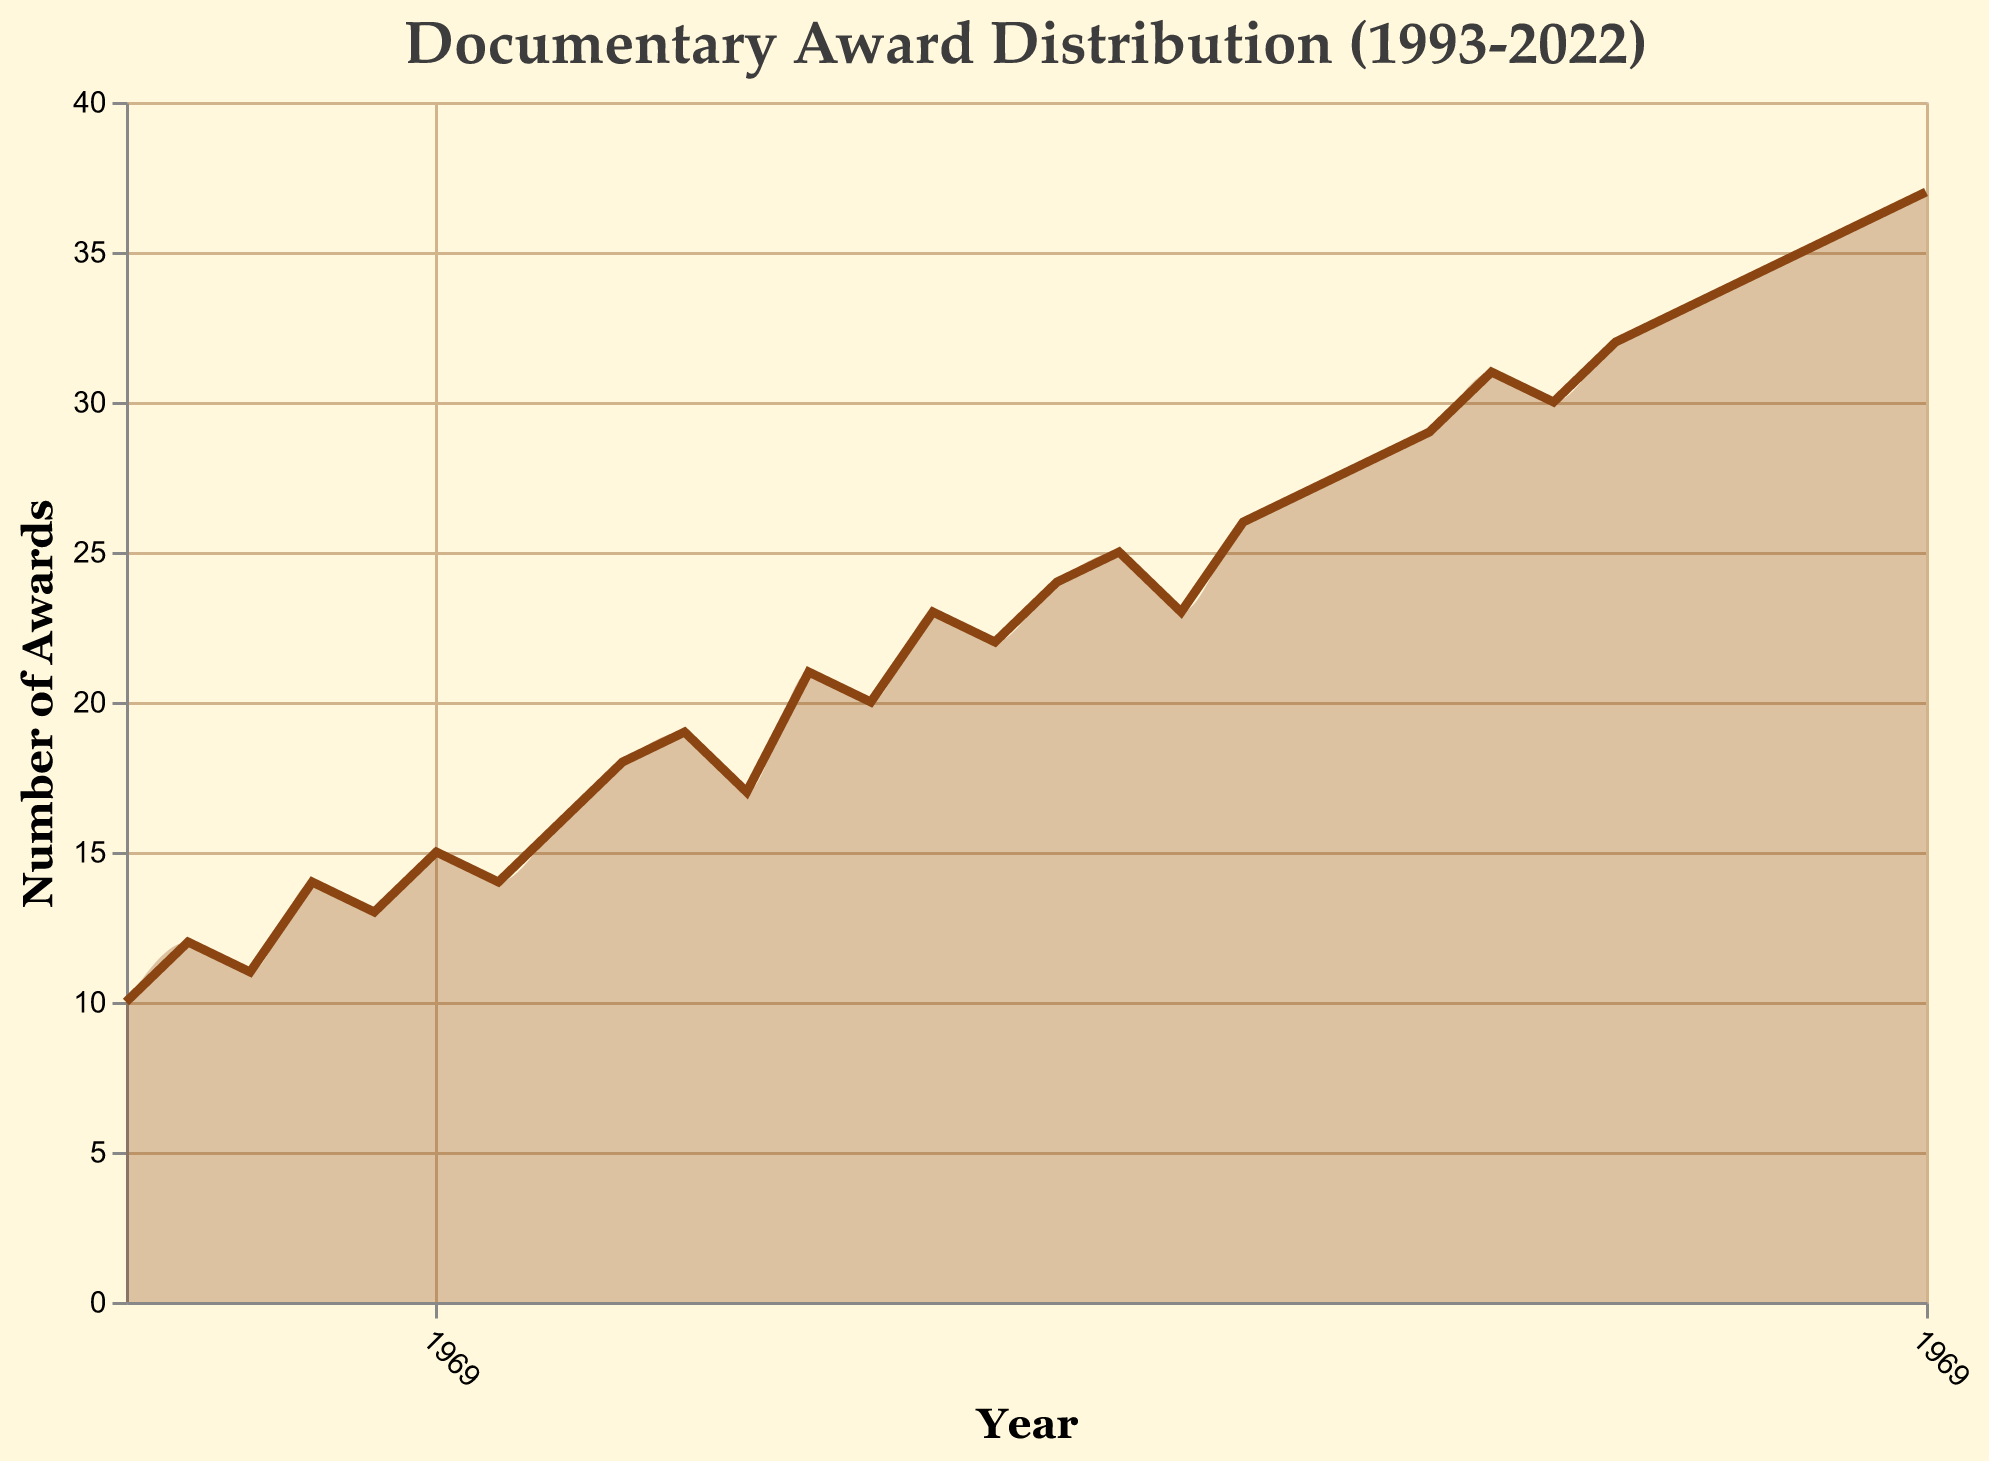What is the title of the figure? The title is prominently displayed at the top of the chart, representing the main subject of the visualization. The title reads "Documentary Award Distribution (1993-2022)", indicating it covers the frequency distribution of documentary awards over the last three decades.
Answer: Documentary Award Distribution (1993-2022) What is the value of awards in the year 2000? To find this, look at the data point corresponding to the year 2000 along the horizontal (x) axis and see its height on the vertical (y) axis. The data point indicates that the number of awards in 2000 was 16.
Answer: 16 In which year was the highest number of awards given? The highest point on the vertical (y) axis will represent the highest number of awards received in a year. By locating the peak, we see that the highest number of awards (37) was given in the year 2022.
Answer: 2022 By how much did the number of awards increase from 1993 to 2022? The number of awards in 1993 was 10, and it increased to 37 in 2022. The increase can be calculated by subtracting the number of awards in 1993 from the number of awards in 2022: 37 - 10.
Answer: 27 During which decade did the number of awards experience the most significant increase? Divide the data into decades and compare the increase in the number of awards within each decade. From 1993 to 2002, the awards increased from 10 to 19 (a difference of 9). From 2003 to 2012, it increased from 17 to 27 (a difference of 10). From 2013 to 2022, it increased from 29 to 37 (a difference of 8). The decade with the most significant increase is from 2003 to 2012.
Answer: 2003-2012 What is the average number of awards given per year over the three decades? Sum all the awards from 1993 to 2022 and divide by the number of years (30). The total sum of awards is 30 + 12 + 11 + 14 + 13 + 15 + 14 + 16 + 18 + 19 + 17 + 21 + 20 + 23 + 22 + 24 + 25 + 23 + 26 + 27 + 28 + 29 + 31 + 30 + 32 + 33 + 34 + 35 + 36 + 37 = 665. The average is 665/30.
Answer: 22.17 How does the number of awards in 2010 compare to that in 2000? Locate both years on the x-axis and compare their values on the y-axis. The value for 2010 is 23 awards, and for 2000 it is 16 awards. To compare, note that 2010 had 7 more awards than 2000.
Answer: 7 more in 2010 Are there any years where the number of awards decreased from the previous year? If so, which years? Check the y-values year by year to determine if the awards for any year are less than those for the preceding year. From the visualization, there are no such years, as the trend is always increasing or remaining the same.
Answer: No What is the most frequent range of awards given in a decade, based on the areas under the line in the graph? Examine the area under the line graph segment for each decade to determine which range is most consistently represented. For the decades mentioned, reviewing the areas would show the awards frequently fall in the range of 10-20, 20-30, and 30-40 across different decades. To pinpoint the most frequent, it involves estimating visually which range appears most often covered by the areas under each segment.
Answer: 20-30 